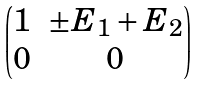Convert formula to latex. <formula><loc_0><loc_0><loc_500><loc_500>\begin{pmatrix} 1 & \pm E _ { 1 } + E _ { 2 } \\ 0 & 0 \end{pmatrix}</formula> 